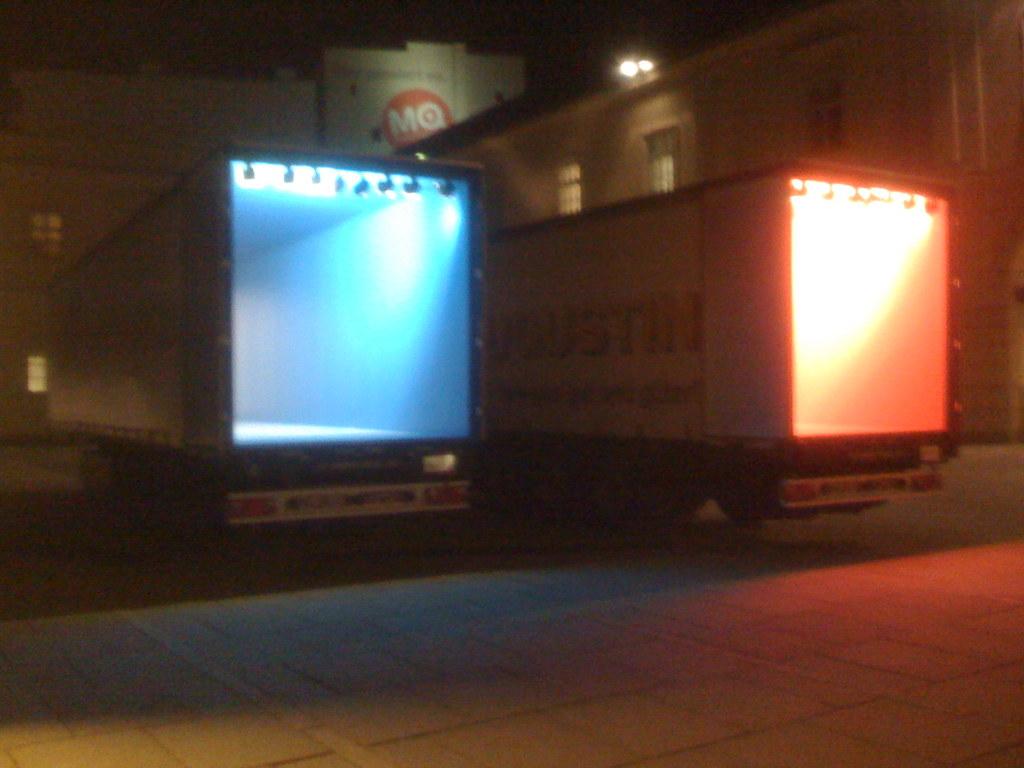What letters are in the red circle above the trucks?
Give a very brief answer. Mq. 